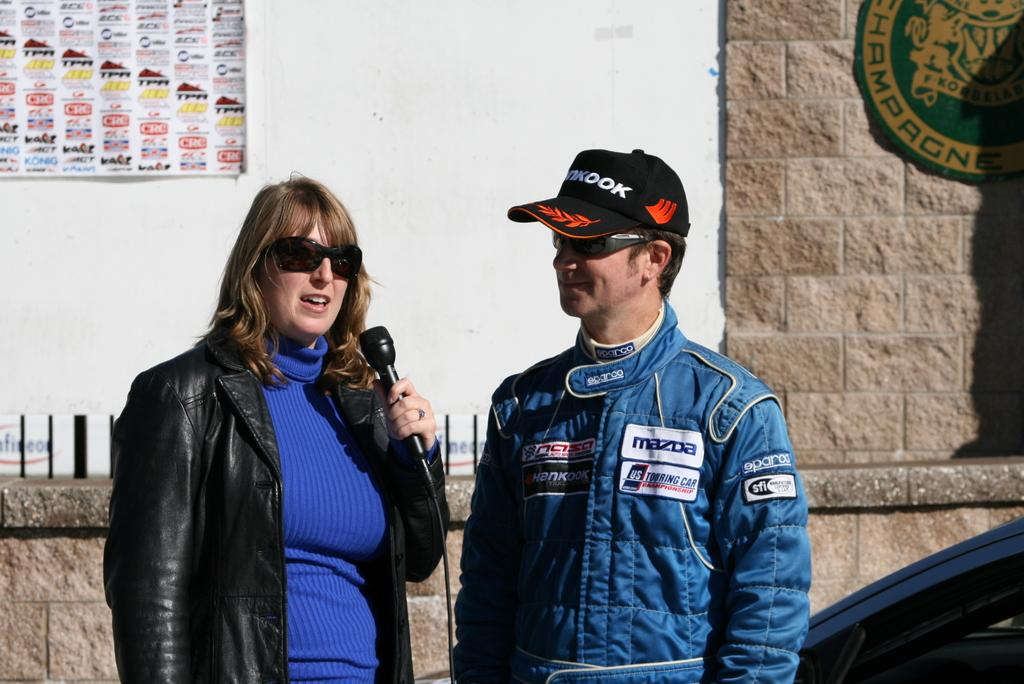Provide a one-sentence caption for the provided image. Male race car driver in a Mazda logo blue jacket standing by a lady. 